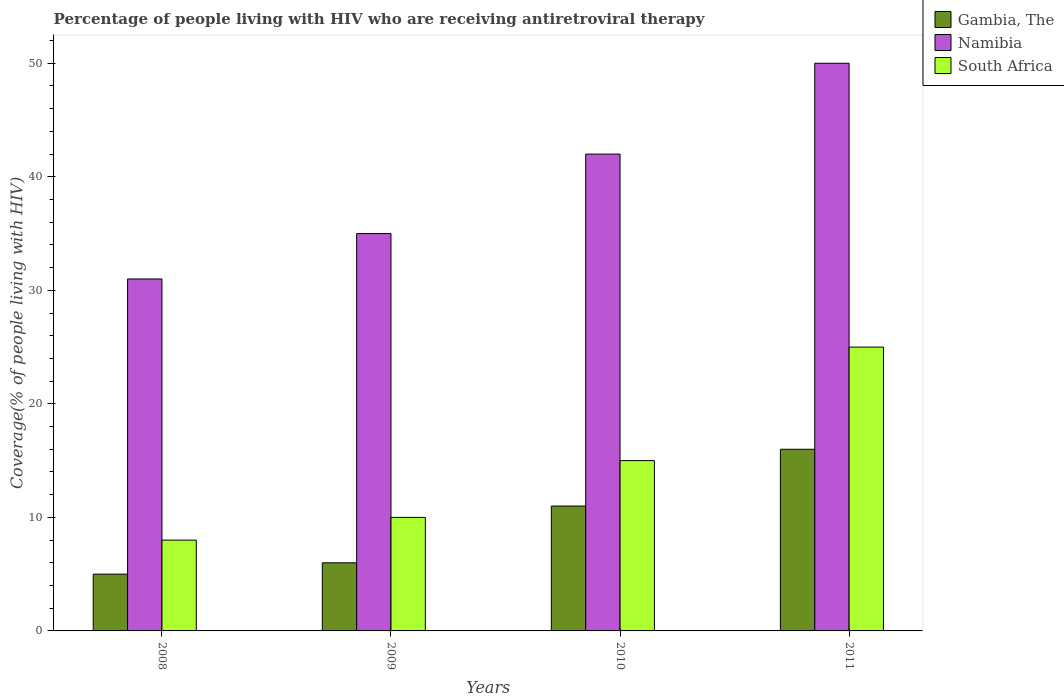How many groups of bars are there?
Provide a short and direct response. 4. Are the number of bars per tick equal to the number of legend labels?
Your answer should be compact. Yes. How many bars are there on the 1st tick from the right?
Keep it short and to the point. 3. In how many cases, is the number of bars for a given year not equal to the number of legend labels?
Make the answer very short. 0. What is the percentage of the HIV infected people who are receiving antiretroviral therapy in Gambia, The in 2011?
Keep it short and to the point. 16. Across all years, what is the maximum percentage of the HIV infected people who are receiving antiretroviral therapy in Gambia, The?
Your response must be concise. 16. Across all years, what is the minimum percentage of the HIV infected people who are receiving antiretroviral therapy in South Africa?
Your answer should be very brief. 8. In which year was the percentage of the HIV infected people who are receiving antiretroviral therapy in South Africa maximum?
Offer a terse response. 2011. What is the total percentage of the HIV infected people who are receiving antiretroviral therapy in South Africa in the graph?
Provide a succinct answer. 58. What is the difference between the percentage of the HIV infected people who are receiving antiretroviral therapy in Gambia, The in 2010 and that in 2011?
Your response must be concise. -5. What is the difference between the percentage of the HIV infected people who are receiving antiretroviral therapy in Namibia in 2011 and the percentage of the HIV infected people who are receiving antiretroviral therapy in South Africa in 2009?
Ensure brevity in your answer.  40. In the year 2008, what is the difference between the percentage of the HIV infected people who are receiving antiretroviral therapy in Gambia, The and percentage of the HIV infected people who are receiving antiretroviral therapy in Namibia?
Your answer should be compact. -26. In how many years, is the percentage of the HIV infected people who are receiving antiretroviral therapy in Gambia, The greater than 28 %?
Provide a succinct answer. 0. What is the ratio of the percentage of the HIV infected people who are receiving antiretroviral therapy in Namibia in 2008 to that in 2009?
Give a very brief answer. 0.89. Is the percentage of the HIV infected people who are receiving antiretroviral therapy in Gambia, The in 2008 less than that in 2011?
Your answer should be compact. Yes. Is the difference between the percentage of the HIV infected people who are receiving antiretroviral therapy in Gambia, The in 2008 and 2011 greater than the difference between the percentage of the HIV infected people who are receiving antiretroviral therapy in Namibia in 2008 and 2011?
Offer a terse response. Yes. What is the difference between the highest and the lowest percentage of the HIV infected people who are receiving antiretroviral therapy in South Africa?
Provide a short and direct response. 17. Is the sum of the percentage of the HIV infected people who are receiving antiretroviral therapy in Gambia, The in 2008 and 2010 greater than the maximum percentage of the HIV infected people who are receiving antiretroviral therapy in South Africa across all years?
Your answer should be compact. No. What does the 2nd bar from the left in 2011 represents?
Offer a terse response. Namibia. What does the 3rd bar from the right in 2011 represents?
Offer a terse response. Gambia, The. How many bars are there?
Offer a terse response. 12. How many years are there in the graph?
Offer a terse response. 4. What is the difference between two consecutive major ticks on the Y-axis?
Give a very brief answer. 10. Are the values on the major ticks of Y-axis written in scientific E-notation?
Make the answer very short. No. Does the graph contain any zero values?
Keep it short and to the point. No. Does the graph contain grids?
Keep it short and to the point. No. Where does the legend appear in the graph?
Your answer should be very brief. Top right. What is the title of the graph?
Offer a very short reply. Percentage of people living with HIV who are receiving antiretroviral therapy. Does "Seychelles" appear as one of the legend labels in the graph?
Your response must be concise. No. What is the label or title of the Y-axis?
Your response must be concise. Coverage(% of people living with HIV). What is the Coverage(% of people living with HIV) in Gambia, The in 2008?
Ensure brevity in your answer.  5. What is the Coverage(% of people living with HIV) in Namibia in 2008?
Provide a succinct answer. 31. What is the Coverage(% of people living with HIV) in South Africa in 2008?
Your answer should be compact. 8. What is the Coverage(% of people living with HIV) of Gambia, The in 2010?
Give a very brief answer. 11. What is the Coverage(% of people living with HIV) in Namibia in 2010?
Provide a short and direct response. 42. What is the Coverage(% of people living with HIV) in Gambia, The in 2011?
Offer a very short reply. 16. What is the Coverage(% of people living with HIV) in Namibia in 2011?
Ensure brevity in your answer.  50. Across all years, what is the minimum Coverage(% of people living with HIV) of Namibia?
Ensure brevity in your answer.  31. What is the total Coverage(% of people living with HIV) of Gambia, The in the graph?
Give a very brief answer. 38. What is the total Coverage(% of people living with HIV) of Namibia in the graph?
Offer a very short reply. 158. What is the total Coverage(% of people living with HIV) of South Africa in the graph?
Ensure brevity in your answer.  58. What is the difference between the Coverage(% of people living with HIV) in South Africa in 2008 and that in 2009?
Your answer should be very brief. -2. What is the difference between the Coverage(% of people living with HIV) in Gambia, The in 2008 and that in 2010?
Your answer should be compact. -6. What is the difference between the Coverage(% of people living with HIV) of Gambia, The in 2008 and that in 2011?
Your response must be concise. -11. What is the difference between the Coverage(% of people living with HIV) in South Africa in 2008 and that in 2011?
Give a very brief answer. -17. What is the difference between the Coverage(% of people living with HIV) of Namibia in 2009 and that in 2010?
Give a very brief answer. -7. What is the difference between the Coverage(% of people living with HIV) of South Africa in 2009 and that in 2010?
Provide a succinct answer. -5. What is the difference between the Coverage(% of people living with HIV) of Gambia, The in 2009 and that in 2011?
Ensure brevity in your answer.  -10. What is the difference between the Coverage(% of people living with HIV) of Gambia, The in 2008 and the Coverage(% of people living with HIV) of Namibia in 2010?
Give a very brief answer. -37. What is the difference between the Coverage(% of people living with HIV) of Gambia, The in 2008 and the Coverage(% of people living with HIV) of South Africa in 2010?
Your answer should be compact. -10. What is the difference between the Coverage(% of people living with HIV) in Namibia in 2008 and the Coverage(% of people living with HIV) in South Africa in 2010?
Your answer should be very brief. 16. What is the difference between the Coverage(% of people living with HIV) in Gambia, The in 2008 and the Coverage(% of people living with HIV) in Namibia in 2011?
Your answer should be very brief. -45. What is the difference between the Coverage(% of people living with HIV) of Gambia, The in 2008 and the Coverage(% of people living with HIV) of South Africa in 2011?
Your answer should be very brief. -20. What is the difference between the Coverage(% of people living with HIV) of Namibia in 2008 and the Coverage(% of people living with HIV) of South Africa in 2011?
Offer a terse response. 6. What is the difference between the Coverage(% of people living with HIV) of Gambia, The in 2009 and the Coverage(% of people living with HIV) of Namibia in 2010?
Give a very brief answer. -36. What is the difference between the Coverage(% of people living with HIV) of Namibia in 2009 and the Coverage(% of people living with HIV) of South Africa in 2010?
Give a very brief answer. 20. What is the difference between the Coverage(% of people living with HIV) in Gambia, The in 2009 and the Coverage(% of people living with HIV) in Namibia in 2011?
Your response must be concise. -44. What is the difference between the Coverage(% of people living with HIV) of Gambia, The in 2009 and the Coverage(% of people living with HIV) of South Africa in 2011?
Give a very brief answer. -19. What is the difference between the Coverage(% of people living with HIV) in Gambia, The in 2010 and the Coverage(% of people living with HIV) in Namibia in 2011?
Keep it short and to the point. -39. What is the difference between the Coverage(% of people living with HIV) in Gambia, The in 2010 and the Coverage(% of people living with HIV) in South Africa in 2011?
Provide a succinct answer. -14. What is the difference between the Coverage(% of people living with HIV) in Namibia in 2010 and the Coverage(% of people living with HIV) in South Africa in 2011?
Your answer should be compact. 17. What is the average Coverage(% of people living with HIV) of Gambia, The per year?
Your answer should be compact. 9.5. What is the average Coverage(% of people living with HIV) of Namibia per year?
Provide a short and direct response. 39.5. In the year 2008, what is the difference between the Coverage(% of people living with HIV) in Namibia and Coverage(% of people living with HIV) in South Africa?
Your answer should be compact. 23. In the year 2009, what is the difference between the Coverage(% of people living with HIV) in Gambia, The and Coverage(% of people living with HIV) in South Africa?
Keep it short and to the point. -4. In the year 2009, what is the difference between the Coverage(% of people living with HIV) in Namibia and Coverage(% of people living with HIV) in South Africa?
Offer a terse response. 25. In the year 2010, what is the difference between the Coverage(% of people living with HIV) of Gambia, The and Coverage(% of people living with HIV) of Namibia?
Provide a succinct answer. -31. In the year 2011, what is the difference between the Coverage(% of people living with HIV) in Gambia, The and Coverage(% of people living with HIV) in Namibia?
Ensure brevity in your answer.  -34. In the year 2011, what is the difference between the Coverage(% of people living with HIV) of Gambia, The and Coverage(% of people living with HIV) of South Africa?
Offer a terse response. -9. In the year 2011, what is the difference between the Coverage(% of people living with HIV) in Namibia and Coverage(% of people living with HIV) in South Africa?
Offer a terse response. 25. What is the ratio of the Coverage(% of people living with HIV) of Gambia, The in 2008 to that in 2009?
Make the answer very short. 0.83. What is the ratio of the Coverage(% of people living with HIV) of Namibia in 2008 to that in 2009?
Make the answer very short. 0.89. What is the ratio of the Coverage(% of people living with HIV) in Gambia, The in 2008 to that in 2010?
Provide a short and direct response. 0.45. What is the ratio of the Coverage(% of people living with HIV) of Namibia in 2008 to that in 2010?
Your answer should be very brief. 0.74. What is the ratio of the Coverage(% of people living with HIV) in South Africa in 2008 to that in 2010?
Your answer should be compact. 0.53. What is the ratio of the Coverage(% of people living with HIV) of Gambia, The in 2008 to that in 2011?
Your response must be concise. 0.31. What is the ratio of the Coverage(% of people living with HIV) of Namibia in 2008 to that in 2011?
Ensure brevity in your answer.  0.62. What is the ratio of the Coverage(% of people living with HIV) of South Africa in 2008 to that in 2011?
Keep it short and to the point. 0.32. What is the ratio of the Coverage(% of people living with HIV) in Gambia, The in 2009 to that in 2010?
Your response must be concise. 0.55. What is the ratio of the Coverage(% of people living with HIV) of Gambia, The in 2009 to that in 2011?
Provide a short and direct response. 0.38. What is the ratio of the Coverage(% of people living with HIV) in Gambia, The in 2010 to that in 2011?
Keep it short and to the point. 0.69. What is the ratio of the Coverage(% of people living with HIV) in Namibia in 2010 to that in 2011?
Give a very brief answer. 0.84. What is the difference between the highest and the second highest Coverage(% of people living with HIV) in Namibia?
Offer a very short reply. 8. What is the difference between the highest and the lowest Coverage(% of people living with HIV) of Gambia, The?
Your answer should be compact. 11. 